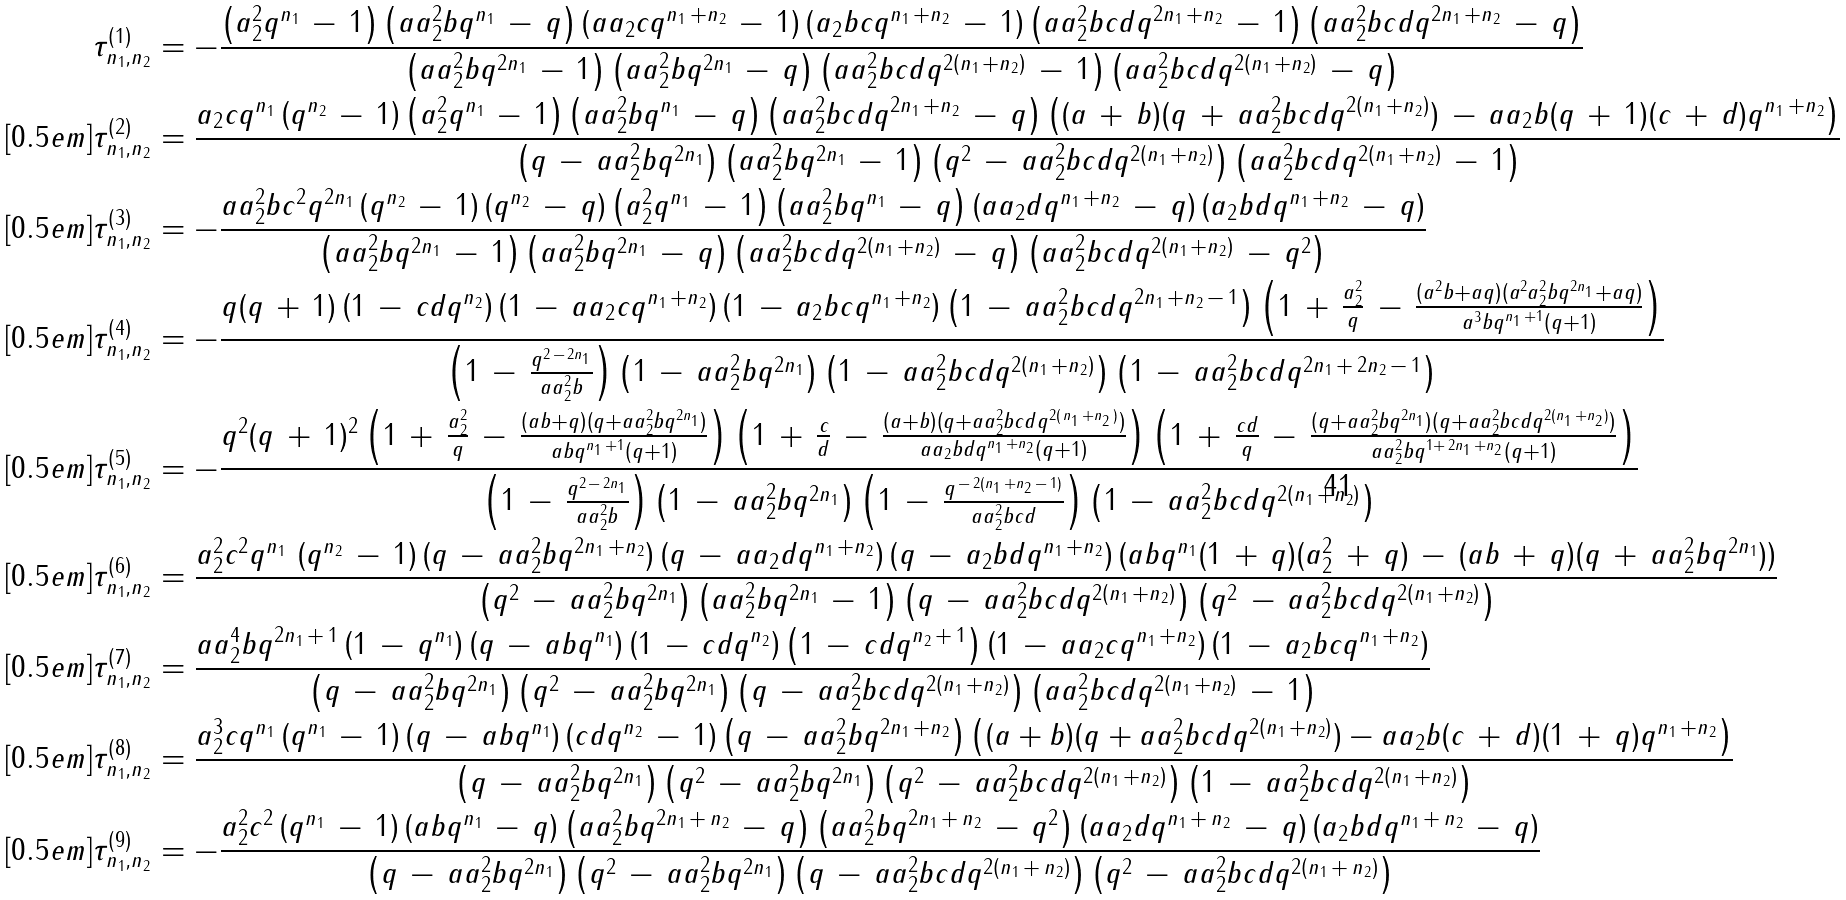<formula> <loc_0><loc_0><loc_500><loc_500>\tau ^ { ( 1 ) } _ { n _ { 1 } , n _ { 2 } } & = - \frac { \left ( a _ { 2 } ^ { 2 } q ^ { n _ { 1 } } \, - \, 1 \right ) \left ( a a _ { 2 } ^ { 2 } b q ^ { n _ { 1 } } \, - \, q \right ) \left ( a a _ { 2 } c q ^ { n _ { 1 } \, + n _ { 2 } } \, - \, 1 \right ) \left ( a _ { 2 } b c q ^ { n _ { 1 } \, + n _ { 2 } } \, - \, 1 \right ) \left ( a a _ { 2 } ^ { 2 } b c d q ^ { 2 n _ { 1 } \, + n _ { 2 } } \, - \, 1 \right ) \left ( a a _ { 2 } ^ { 2 } b c d q ^ { 2 n _ { 1 } \, + n _ { 2 } } \, - \, q \right ) } { \left ( a a _ { 2 } ^ { 2 } b q ^ { 2 n _ { 1 } } \, - \, 1 \right ) \left ( a a _ { 2 } ^ { 2 } b q ^ { 2 n _ { 1 } } \, - \, q \right ) \left ( a a _ { 2 } ^ { 2 } b c d q ^ { 2 ( n _ { 1 } \, + n _ { 2 } ) } \, - \, 1 \right ) \left ( a a _ { 2 } ^ { 2 } b c d q ^ { 2 ( n _ { 1 } \, + n _ { 2 } ) } \, - \, q \right ) } \\ [ 0 . 5 e m ] \tau ^ { ( 2 ) } _ { n _ { 1 } , n _ { 2 } } & = \frac { a _ { 2 } c q ^ { n _ { 1 } } \left ( q ^ { n _ { 2 } } \, - \, 1 \right ) \left ( a _ { 2 } ^ { 2 } q ^ { n _ { 1 } } \, - \, 1 \right ) \left ( a a _ { 2 } ^ { 2 } b q ^ { n _ { 1 } } \, - \, q \right ) \left ( a a _ { 2 } ^ { 2 } b c d q ^ { 2 n _ { 1 } \, + n _ { 2 } } \, - \, q \right ) \left ( ( a \, + \, b ) ( q \, + \, a a _ { 2 } ^ { 2 } b c d q ^ { 2 ( n _ { 1 } \, + n _ { 2 } ) } ) \, - \, a a _ { 2 } b ( q \, + \, 1 ) ( c \, + \, d ) q ^ { n _ { 1 } \, + n _ { 2 } } \right ) } { \left ( q \, - \, a a _ { 2 } ^ { 2 } b q ^ { 2 n _ { 1 } } \right ) \left ( a a _ { 2 } ^ { 2 } b q ^ { 2 n _ { 1 } } \, - \, 1 \right ) \left ( q ^ { 2 } \, - \, a a _ { 2 } ^ { 2 } b c d q ^ { 2 ( n _ { 1 } \, + n _ { 2 } ) } \right ) \left ( a a _ { 2 } ^ { 2 } b c d q ^ { 2 ( n _ { 1 } \, + n _ { 2 } ) } \, - \, 1 \right ) } \\ [ 0 . 5 e m ] \tau ^ { ( 3 ) } _ { n _ { 1 } , n _ { 2 } } & = - \frac { a a _ { 2 } ^ { 2 } b c ^ { 2 } q ^ { 2 n _ { 1 } } \left ( q ^ { n _ { 2 } } \, - \, 1 \right ) \left ( q ^ { n _ { 2 } } \, - \, q \right ) \left ( a _ { 2 } ^ { 2 } q ^ { n _ { 1 } } \, - \, 1 \right ) \left ( a a _ { 2 } ^ { 2 } b q ^ { n _ { 1 } } \, - \, q \right ) \left ( a a _ { 2 } d q ^ { n _ { 1 } \, + n _ { 2 } } \, - \, q \right ) \left ( a _ { 2 } b d q ^ { n _ { 1 } \, + n _ { 2 } } \, - \, q \right ) } { \left ( a a _ { 2 } ^ { 2 } b q ^ { 2 n _ { 1 } } \, - \, 1 \right ) \left ( a a _ { 2 } ^ { 2 } b q ^ { 2 n _ { 1 } } \, - \, q \right ) \left ( a a _ { 2 } ^ { 2 } b c d q ^ { 2 ( n _ { 1 } \, + n _ { 2 } ) } \, - \, q \right ) \left ( a a _ { 2 } ^ { 2 } b c d q ^ { 2 ( n _ { 1 } \, + n _ { 2 } ) } \, - \, q ^ { 2 } \right ) } \\ [ 0 . 5 e m ] \tau ^ { ( 4 ) } _ { n _ { 1 } , n _ { 2 } } & = - \frac { q ( q \, + \, 1 ) \left ( 1 \, - \, c d q ^ { n _ { 2 } } \right ) \left ( 1 \, - \, a a _ { 2 } c q ^ { n _ { 1 } \, + n _ { 2 } } \right ) \left ( 1 \, - \, a _ { 2 } b c q ^ { n _ { 1 } \, + n _ { 2 } } \right ) \left ( 1 \, - \, a a _ { 2 } ^ { 2 } b c d q ^ { 2 n _ { 1 } \, + n _ { 2 } \, - \, 1 } \right ) \left ( 1 \, + \, \frac { a _ { 2 } ^ { 2 } } { q } \, - \, \frac { ( a ^ { 2 } b + a q ) ( a ^ { 2 } a _ { 2 } ^ { 2 } b q ^ { 2 n _ { 1 } } + a q ) } { a ^ { 3 } b q ^ { n _ { 1 } \, + 1 } ( q + 1 ) } \right ) } { \left ( 1 \, - \, \frac { q ^ { 2 \, - \, 2 n _ { 1 } } } { a a _ { 2 } ^ { 2 } b } \right ) \left ( 1 \, - \, a a _ { 2 } ^ { 2 } b q ^ { 2 n _ { 1 } } \right ) \left ( 1 \, - \, a a _ { 2 } ^ { 2 } b c d q ^ { 2 ( n _ { 1 } \, + n _ { 2 } ) } \right ) \left ( 1 \, - \, a a _ { 2 } ^ { 2 } b c d q ^ { 2 n _ { 1 } \, + \, 2 n _ { 2 } \, - \, 1 } \right ) } \\ [ 0 . 5 e m ] \tau ^ { ( 5 ) } _ { n _ { 1 } , n _ { 2 } } & = - \frac { q ^ { 2 } ( q \, + \, 1 ) ^ { 2 } \left ( 1 \, + \, \frac { a _ { 2 } ^ { 2 } } { q } \, - \, \frac { ( a b + q ) ( q + a a _ { 2 } ^ { 2 } b q ^ { 2 n _ { 1 } } ) } { a b q ^ { n _ { 1 } \, + 1 } ( q + 1 ) } \right ) \left ( 1 \, + \, \frac { c } { d } \, - \, \frac { ( a + b ) ( q + a a _ { 2 } ^ { 2 } b c d q ^ { 2 ( \, n _ { 1 } \, + n _ { 2 } \, ) } ) } { a a _ { 2 } b d q ^ { n _ { 1 } \, + n _ { 2 } } ( q + 1 ) } \right ) \left ( 1 \, + \, \frac { c d } { q } \, - \, \frac { ( q + a a _ { 2 } ^ { 2 } b q ^ { 2 n _ { 1 } } ) ( q + a a _ { 2 } ^ { 2 } b c d q ^ { 2 ( n _ { 1 } \, + n _ { 2 } ) } ) } { a a _ { 2 } ^ { 2 } b q ^ { 1 + \, 2 n _ { 1 } \, + n _ { 2 } } ( q + 1 ) } \right ) } { \left ( 1 \, - \, \frac { q ^ { 2 \, - \, 2 n _ { 1 } } } { a a _ { 2 } ^ { 2 } b } \right ) \left ( 1 \, - \, a a _ { 2 } ^ { 2 } b q ^ { 2 n _ { 1 } } \right ) \left ( 1 \, - \, \frac { q ^ { \, - \, 2 ( n _ { 1 } \, + n _ { 2 } \, - \, 1 ) } } { a a _ { 2 } ^ { 2 } b c d } \right ) \left ( 1 \, - \, a a _ { 2 } ^ { 2 } b c d q ^ { 2 ( n _ { 1 } \, + n _ { 2 } ) } \right ) } \\ [ 0 . 5 e m ] \tau ^ { ( 6 ) } _ { n _ { 1 } , n _ { 2 } } & = \frac { a _ { 2 } ^ { 2 } c ^ { 2 } q ^ { n _ { 1 } } \, \left ( q ^ { n _ { 2 } } \, - \, 1 \right ) ( q \, - \, a a _ { 2 } ^ { 2 } b q ^ { 2 n _ { 1 } \, + n _ { 2 } } ) \left ( q \, - \, a a _ { 2 } d q ^ { n _ { 1 } \, + n _ { 2 } } \right ) \left ( q \, - \, a _ { 2 } b d q ^ { n _ { 1 } \, + n _ { 2 } } \right ) ( a b q ^ { n _ { 1 } } ( 1 \, + \, q ) ( a _ { 2 } ^ { 2 } \, + \, q ) \, - \, ( a b \, + \, q ) ( q \, + \, a a _ { 2 } ^ { 2 } b q ^ { 2 n _ { 1 } } ) ) } { \left ( q ^ { 2 } \, - \, a a _ { 2 } ^ { 2 } b q ^ { 2 n _ { 1 } } \right ) \left ( a a _ { 2 } ^ { 2 } b q ^ { 2 n _ { 1 } } \, - \, 1 \right ) \left ( q \, - \, a a _ { 2 } ^ { 2 } b c d q ^ { 2 ( n _ { 1 } \, + n _ { 2 } ) } \right ) \left ( q ^ { 2 } \, - \, a a _ { 2 } ^ { 2 } b c d q ^ { 2 ( n _ { 1 } \, + n _ { 2 } ) } \right ) } \\ [ 0 . 5 e m ] \tau ^ { ( 7 ) } _ { n _ { 1 } , n _ { 2 } } & = \frac { a a _ { 2 } ^ { 4 } b q ^ { 2 n _ { 1 } \, + \, 1 } \left ( 1 \, - \, q ^ { n _ { 1 } } \right ) \left ( q \, - \, a b q ^ { n _ { 1 } } \right ) \left ( 1 \, - \, c d q ^ { n _ { 2 } } \right ) \left ( 1 \, - \, c d q ^ { n _ { 2 } \, + \, 1 } \right ) \left ( 1 \, - \, a a _ { 2 } c q ^ { n _ { 1 } \, + n _ { 2 } } \right ) \left ( 1 \, - \, a _ { 2 } b c q ^ { n _ { 1 } \, + n _ { 2 } } \right ) } { \left ( q \, - \, a a _ { 2 } ^ { 2 } b q ^ { 2 n _ { 1 } } \right ) \left ( q ^ { 2 } \, - \, a a _ { 2 } ^ { 2 } b q ^ { 2 n _ { 1 } } \right ) \left ( q \, - \, a a _ { 2 } ^ { 2 } b c d q ^ { 2 ( n _ { 1 } \, + n _ { 2 } ) } \right ) \left ( a a _ { 2 } ^ { 2 } b c d q ^ { 2 ( n _ { 1 } \, + n _ { 2 } ) } \, - \, 1 \right ) } \\ [ 0 . 5 e m ] \tau ^ { ( 8 ) } _ { n _ { 1 } , n _ { 2 } } & = \frac { a _ { 2 } ^ { 3 } c q ^ { n _ { 1 } } \left ( q ^ { n _ { 1 } } \, - \, 1 \right ) \left ( q \, - \, a b q ^ { n _ { 1 } } \right ) \left ( c d q ^ { n _ { 2 } } \, - \, 1 \right ) \left ( q \, - \, a a _ { 2 } ^ { 2 } b q ^ { 2 n _ { 1 } \, + n _ { 2 } } \right ) \left ( ( a + b ) ( q + a a _ { 2 } ^ { 2 } b c d q ^ { 2 ( n _ { 1 } \, + n _ { 2 } ) } ) - a a _ { 2 } b ( c \, + \, d ) ( 1 \, + \, q ) q ^ { n _ { 1 } \, + n _ { 2 } } \right ) } { \left ( q \, - \, a a _ { 2 } ^ { 2 } b q ^ { 2 n _ { 1 } } \right ) \left ( q ^ { 2 } \, - \, a a _ { 2 } ^ { 2 } b q ^ { 2 n _ { 1 } } \right ) \left ( q ^ { 2 } \, - \, a a _ { 2 } ^ { 2 } b c d q ^ { 2 ( n _ { 1 } \, + n _ { 2 } ) } \right ) \left ( 1 \, - \, a a _ { 2 } ^ { 2 } b c d q ^ { 2 ( n _ { 1 } \, + n _ { 2 } ) } \right ) } \\ [ 0 . 5 e m ] \tau ^ { ( 9 ) } _ { n _ { 1 } , n _ { 2 } } & = - \frac { a _ { 2 } ^ { 2 } c ^ { 2 } \left ( q ^ { n _ { 1 } } \, - \, 1 \right ) \left ( a b q ^ { n _ { 1 } } \, - \, q \right ) \left ( a a _ { 2 } ^ { 2 } b q ^ { 2 n _ { 1 } \, + \, n _ { 2 } } \, - \, q \right ) \left ( a a _ { 2 } ^ { 2 } b q ^ { 2 n _ { 1 } \, + \, n _ { 2 } } \, - \, q ^ { 2 } \right ) \left ( a a _ { 2 } d q ^ { n _ { 1 } \, + \, n _ { 2 } } \, - \, q \right ) \left ( a _ { 2 } b d q ^ { n _ { 1 } \, + \, n _ { 2 } } \, - \, q \right ) } { \left ( q \, - \, a a _ { 2 } ^ { 2 } b q ^ { 2 n _ { 1 } } \right ) \left ( q ^ { 2 } \, - \, a a _ { 2 } ^ { 2 } b q ^ { 2 n _ { 1 } } \right ) \left ( q \, - \, a a _ { 2 } ^ { 2 } b c d q ^ { 2 ( n _ { 1 } \, + \, n _ { 2 } ) } \right ) \left ( q ^ { 2 } \, - \, a a _ { 2 } ^ { 2 } b c d q ^ { 2 ( n _ { 1 } \, + \, n _ { 2 } ) } \right ) }</formula> 